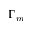<formula> <loc_0><loc_0><loc_500><loc_500>\Gamma _ { m }</formula> 